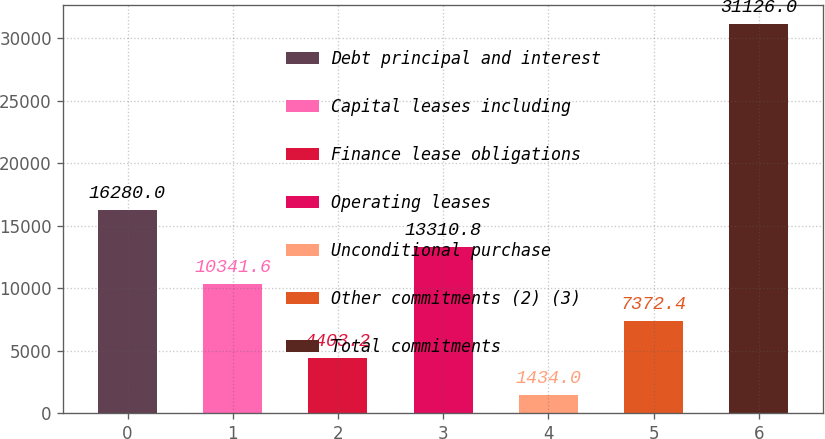Convert chart to OTSL. <chart><loc_0><loc_0><loc_500><loc_500><bar_chart><fcel>Debt principal and interest<fcel>Capital leases including<fcel>Finance lease obligations<fcel>Operating leases<fcel>Unconditional purchase<fcel>Other commitments (2) (3)<fcel>Total commitments<nl><fcel>16280<fcel>10341.6<fcel>4403.2<fcel>13310.8<fcel>1434<fcel>7372.4<fcel>31126<nl></chart> 